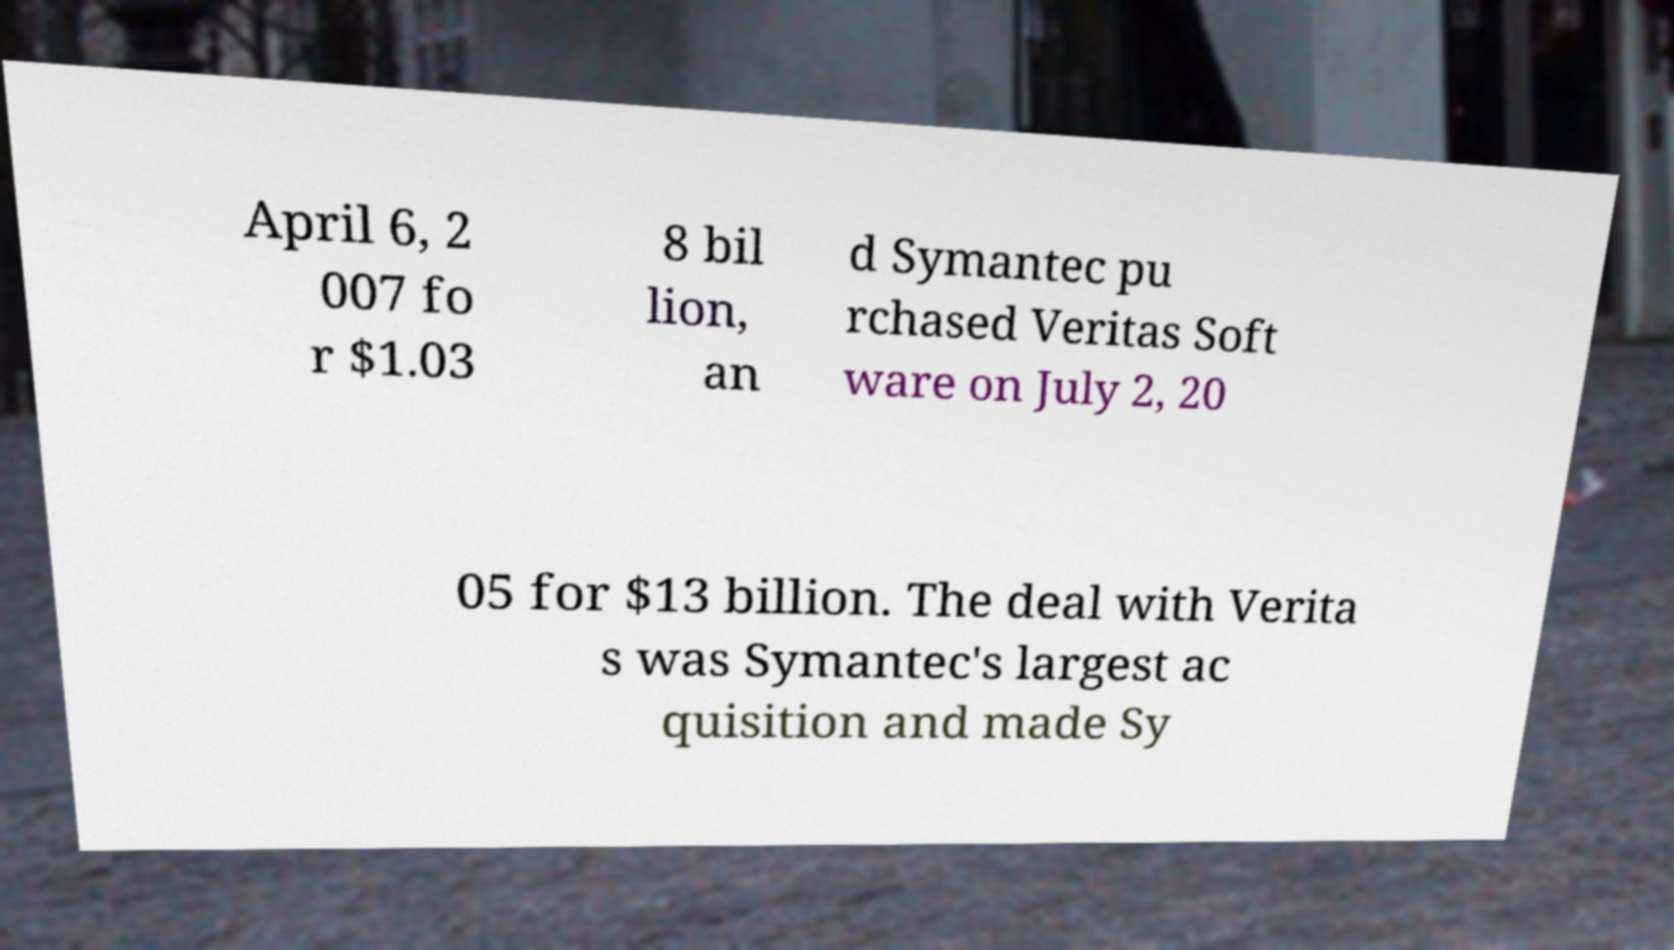Please identify and transcribe the text found in this image. April 6, 2 007 fo r $1.03 8 bil lion, an d Symantec pu rchased Veritas Soft ware on July 2, 20 05 for $13 billion. The deal with Verita s was Symantec's largest ac quisition and made Sy 